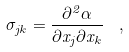<formula> <loc_0><loc_0><loc_500><loc_500>\sigma _ { j k } = \frac { \partial ^ { 2 } \alpha } { \partial x _ { j } \partial x _ { k } } \ \ ,</formula> 